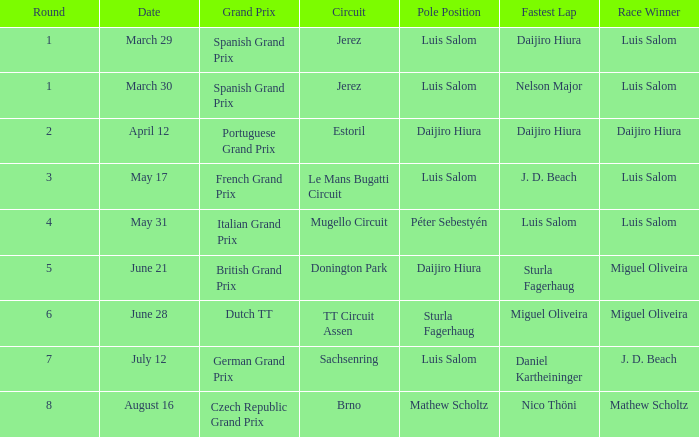In which prominent contests did daijiro hiura claim victory? Portuguese Grand Prix. 